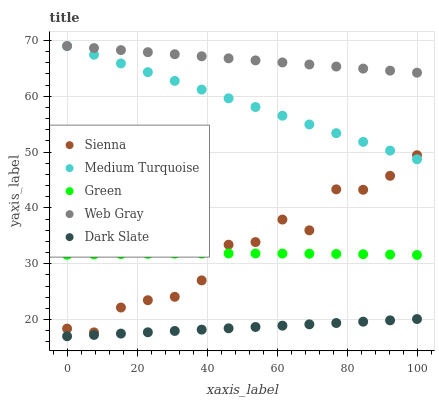Does Dark Slate have the minimum area under the curve?
Answer yes or no. Yes. Does Web Gray have the maximum area under the curve?
Answer yes or no. Yes. Does Web Gray have the minimum area under the curve?
Answer yes or no. No. Does Dark Slate have the maximum area under the curve?
Answer yes or no. No. Is Dark Slate the smoothest?
Answer yes or no. Yes. Is Sienna the roughest?
Answer yes or no. Yes. Is Web Gray the smoothest?
Answer yes or no. No. Is Web Gray the roughest?
Answer yes or no. No. Does Dark Slate have the lowest value?
Answer yes or no. Yes. Does Web Gray have the lowest value?
Answer yes or no. No. Does Medium Turquoise have the highest value?
Answer yes or no. Yes. Does Dark Slate have the highest value?
Answer yes or no. No. Is Green less than Web Gray?
Answer yes or no. Yes. Is Sienna greater than Dark Slate?
Answer yes or no. Yes. Does Web Gray intersect Medium Turquoise?
Answer yes or no. Yes. Is Web Gray less than Medium Turquoise?
Answer yes or no. No. Is Web Gray greater than Medium Turquoise?
Answer yes or no. No. Does Green intersect Web Gray?
Answer yes or no. No. 